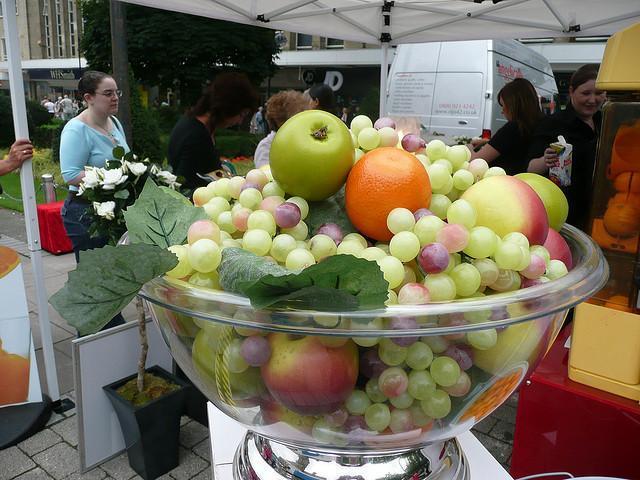Does the image validate the caption "The bowl is at the back of the truck."?
Answer yes or no. Yes. Does the image validate the caption "The bowl is on the truck."?
Answer yes or no. No. Does the image validate the caption "The truck is far from the bowl."?
Answer yes or no. Yes. Does the image validate the caption "The truck is behind the bowl."?
Answer yes or no. Yes. Does the image validate the caption "The bowl is far from the truck."?
Answer yes or no. Yes. 